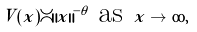<formula> <loc_0><loc_0><loc_500><loc_500>V ( x ) \asymp \| x \| ^ { - \theta } \text { as } x \to \infty ,</formula> 